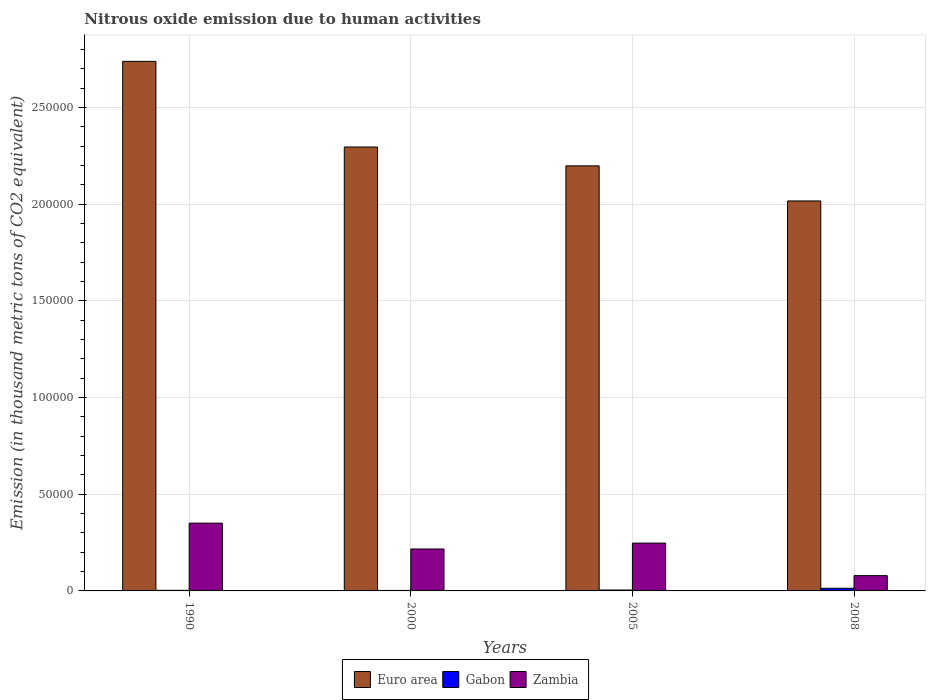How many groups of bars are there?
Ensure brevity in your answer.  4. Are the number of bars on each tick of the X-axis equal?
Your response must be concise. Yes. How many bars are there on the 1st tick from the left?
Make the answer very short. 3. How many bars are there on the 3rd tick from the right?
Your answer should be very brief. 3. In how many cases, is the number of bars for a given year not equal to the number of legend labels?
Offer a very short reply. 0. What is the amount of nitrous oxide emitted in Euro area in 2008?
Give a very brief answer. 2.02e+05. Across all years, what is the maximum amount of nitrous oxide emitted in Gabon?
Your answer should be compact. 1370. Across all years, what is the minimum amount of nitrous oxide emitted in Zambia?
Keep it short and to the point. 7906.4. In which year was the amount of nitrous oxide emitted in Euro area maximum?
Offer a very short reply. 1990. What is the total amount of nitrous oxide emitted in Euro area in the graph?
Your answer should be very brief. 9.25e+05. What is the difference between the amount of nitrous oxide emitted in Zambia in 1990 and that in 2005?
Provide a short and direct response. 1.03e+04. What is the difference between the amount of nitrous oxide emitted in Euro area in 2005 and the amount of nitrous oxide emitted in Gabon in 1990?
Offer a terse response. 2.19e+05. What is the average amount of nitrous oxide emitted in Gabon per year?
Ensure brevity in your answer.  602.27. In the year 2000, what is the difference between the amount of nitrous oxide emitted in Zambia and amount of nitrous oxide emitted in Gabon?
Give a very brief answer. 2.14e+04. In how many years, is the amount of nitrous oxide emitted in Euro area greater than 250000 thousand metric tons?
Your answer should be compact. 1. What is the ratio of the amount of nitrous oxide emitted in Euro area in 1990 to that in 2005?
Keep it short and to the point. 1.25. Is the difference between the amount of nitrous oxide emitted in Zambia in 1990 and 2008 greater than the difference between the amount of nitrous oxide emitted in Gabon in 1990 and 2008?
Your answer should be compact. Yes. What is the difference between the highest and the second highest amount of nitrous oxide emitted in Gabon?
Provide a succinct answer. 892.9. What is the difference between the highest and the lowest amount of nitrous oxide emitted in Gabon?
Your response must be concise. 1115.1. In how many years, is the amount of nitrous oxide emitted in Euro area greater than the average amount of nitrous oxide emitted in Euro area taken over all years?
Offer a terse response. 1. What does the 1st bar from the left in 2008 represents?
Your answer should be very brief. Euro area. What does the 1st bar from the right in 2000 represents?
Your answer should be compact. Zambia. Is it the case that in every year, the sum of the amount of nitrous oxide emitted in Euro area and amount of nitrous oxide emitted in Zambia is greater than the amount of nitrous oxide emitted in Gabon?
Provide a short and direct response. Yes. Are all the bars in the graph horizontal?
Your answer should be compact. No. Are the values on the major ticks of Y-axis written in scientific E-notation?
Provide a short and direct response. No. Does the graph contain grids?
Make the answer very short. Yes. How many legend labels are there?
Make the answer very short. 3. How are the legend labels stacked?
Offer a very short reply. Horizontal. What is the title of the graph?
Offer a very short reply. Nitrous oxide emission due to human activities. Does "Heavily indebted poor countries" appear as one of the legend labels in the graph?
Your answer should be compact. No. What is the label or title of the X-axis?
Your answer should be compact. Years. What is the label or title of the Y-axis?
Ensure brevity in your answer.  Emission (in thousand metric tons of CO2 equivalent). What is the Emission (in thousand metric tons of CO2 equivalent) of Euro area in 1990?
Your answer should be compact. 2.74e+05. What is the Emission (in thousand metric tons of CO2 equivalent) of Gabon in 1990?
Ensure brevity in your answer.  307.1. What is the Emission (in thousand metric tons of CO2 equivalent) in Zambia in 1990?
Offer a terse response. 3.50e+04. What is the Emission (in thousand metric tons of CO2 equivalent) in Euro area in 2000?
Offer a terse response. 2.30e+05. What is the Emission (in thousand metric tons of CO2 equivalent) in Gabon in 2000?
Offer a terse response. 254.9. What is the Emission (in thousand metric tons of CO2 equivalent) in Zambia in 2000?
Your answer should be very brief. 2.17e+04. What is the Emission (in thousand metric tons of CO2 equivalent) in Euro area in 2005?
Make the answer very short. 2.20e+05. What is the Emission (in thousand metric tons of CO2 equivalent) of Gabon in 2005?
Give a very brief answer. 477.1. What is the Emission (in thousand metric tons of CO2 equivalent) of Zambia in 2005?
Your response must be concise. 2.47e+04. What is the Emission (in thousand metric tons of CO2 equivalent) in Euro area in 2008?
Give a very brief answer. 2.02e+05. What is the Emission (in thousand metric tons of CO2 equivalent) in Gabon in 2008?
Keep it short and to the point. 1370. What is the Emission (in thousand metric tons of CO2 equivalent) of Zambia in 2008?
Ensure brevity in your answer.  7906.4. Across all years, what is the maximum Emission (in thousand metric tons of CO2 equivalent) of Euro area?
Offer a very short reply. 2.74e+05. Across all years, what is the maximum Emission (in thousand metric tons of CO2 equivalent) in Gabon?
Keep it short and to the point. 1370. Across all years, what is the maximum Emission (in thousand metric tons of CO2 equivalent) in Zambia?
Your response must be concise. 3.50e+04. Across all years, what is the minimum Emission (in thousand metric tons of CO2 equivalent) in Euro area?
Provide a short and direct response. 2.02e+05. Across all years, what is the minimum Emission (in thousand metric tons of CO2 equivalent) in Gabon?
Your response must be concise. 254.9. Across all years, what is the minimum Emission (in thousand metric tons of CO2 equivalent) in Zambia?
Give a very brief answer. 7906.4. What is the total Emission (in thousand metric tons of CO2 equivalent) in Euro area in the graph?
Your response must be concise. 9.25e+05. What is the total Emission (in thousand metric tons of CO2 equivalent) of Gabon in the graph?
Your answer should be very brief. 2409.1. What is the total Emission (in thousand metric tons of CO2 equivalent) of Zambia in the graph?
Your response must be concise. 8.94e+04. What is the difference between the Emission (in thousand metric tons of CO2 equivalent) in Euro area in 1990 and that in 2000?
Your response must be concise. 4.43e+04. What is the difference between the Emission (in thousand metric tons of CO2 equivalent) of Gabon in 1990 and that in 2000?
Your response must be concise. 52.2. What is the difference between the Emission (in thousand metric tons of CO2 equivalent) in Zambia in 1990 and that in 2000?
Offer a terse response. 1.33e+04. What is the difference between the Emission (in thousand metric tons of CO2 equivalent) of Euro area in 1990 and that in 2005?
Offer a very short reply. 5.40e+04. What is the difference between the Emission (in thousand metric tons of CO2 equivalent) in Gabon in 1990 and that in 2005?
Your answer should be compact. -170. What is the difference between the Emission (in thousand metric tons of CO2 equivalent) of Zambia in 1990 and that in 2005?
Your answer should be very brief. 1.03e+04. What is the difference between the Emission (in thousand metric tons of CO2 equivalent) in Euro area in 1990 and that in 2008?
Make the answer very short. 7.22e+04. What is the difference between the Emission (in thousand metric tons of CO2 equivalent) of Gabon in 1990 and that in 2008?
Your response must be concise. -1062.9. What is the difference between the Emission (in thousand metric tons of CO2 equivalent) in Zambia in 1990 and that in 2008?
Make the answer very short. 2.71e+04. What is the difference between the Emission (in thousand metric tons of CO2 equivalent) in Euro area in 2000 and that in 2005?
Your answer should be compact. 9758.6. What is the difference between the Emission (in thousand metric tons of CO2 equivalent) of Gabon in 2000 and that in 2005?
Offer a very short reply. -222.2. What is the difference between the Emission (in thousand metric tons of CO2 equivalent) in Zambia in 2000 and that in 2005?
Your response must be concise. -3036.8. What is the difference between the Emission (in thousand metric tons of CO2 equivalent) of Euro area in 2000 and that in 2008?
Keep it short and to the point. 2.79e+04. What is the difference between the Emission (in thousand metric tons of CO2 equivalent) of Gabon in 2000 and that in 2008?
Provide a short and direct response. -1115.1. What is the difference between the Emission (in thousand metric tons of CO2 equivalent) in Zambia in 2000 and that in 2008?
Offer a terse response. 1.38e+04. What is the difference between the Emission (in thousand metric tons of CO2 equivalent) in Euro area in 2005 and that in 2008?
Make the answer very short. 1.81e+04. What is the difference between the Emission (in thousand metric tons of CO2 equivalent) of Gabon in 2005 and that in 2008?
Your answer should be compact. -892.9. What is the difference between the Emission (in thousand metric tons of CO2 equivalent) in Zambia in 2005 and that in 2008?
Your answer should be compact. 1.68e+04. What is the difference between the Emission (in thousand metric tons of CO2 equivalent) of Euro area in 1990 and the Emission (in thousand metric tons of CO2 equivalent) of Gabon in 2000?
Offer a very short reply. 2.74e+05. What is the difference between the Emission (in thousand metric tons of CO2 equivalent) of Euro area in 1990 and the Emission (in thousand metric tons of CO2 equivalent) of Zambia in 2000?
Offer a terse response. 2.52e+05. What is the difference between the Emission (in thousand metric tons of CO2 equivalent) of Gabon in 1990 and the Emission (in thousand metric tons of CO2 equivalent) of Zambia in 2000?
Make the answer very short. -2.14e+04. What is the difference between the Emission (in thousand metric tons of CO2 equivalent) in Euro area in 1990 and the Emission (in thousand metric tons of CO2 equivalent) in Gabon in 2005?
Ensure brevity in your answer.  2.73e+05. What is the difference between the Emission (in thousand metric tons of CO2 equivalent) in Euro area in 1990 and the Emission (in thousand metric tons of CO2 equivalent) in Zambia in 2005?
Provide a succinct answer. 2.49e+05. What is the difference between the Emission (in thousand metric tons of CO2 equivalent) in Gabon in 1990 and the Emission (in thousand metric tons of CO2 equivalent) in Zambia in 2005?
Provide a succinct answer. -2.44e+04. What is the difference between the Emission (in thousand metric tons of CO2 equivalent) of Euro area in 1990 and the Emission (in thousand metric tons of CO2 equivalent) of Gabon in 2008?
Offer a terse response. 2.72e+05. What is the difference between the Emission (in thousand metric tons of CO2 equivalent) of Euro area in 1990 and the Emission (in thousand metric tons of CO2 equivalent) of Zambia in 2008?
Provide a succinct answer. 2.66e+05. What is the difference between the Emission (in thousand metric tons of CO2 equivalent) of Gabon in 1990 and the Emission (in thousand metric tons of CO2 equivalent) of Zambia in 2008?
Ensure brevity in your answer.  -7599.3. What is the difference between the Emission (in thousand metric tons of CO2 equivalent) in Euro area in 2000 and the Emission (in thousand metric tons of CO2 equivalent) in Gabon in 2005?
Offer a terse response. 2.29e+05. What is the difference between the Emission (in thousand metric tons of CO2 equivalent) in Euro area in 2000 and the Emission (in thousand metric tons of CO2 equivalent) in Zambia in 2005?
Ensure brevity in your answer.  2.05e+05. What is the difference between the Emission (in thousand metric tons of CO2 equivalent) of Gabon in 2000 and the Emission (in thousand metric tons of CO2 equivalent) of Zambia in 2005?
Give a very brief answer. -2.45e+04. What is the difference between the Emission (in thousand metric tons of CO2 equivalent) of Euro area in 2000 and the Emission (in thousand metric tons of CO2 equivalent) of Gabon in 2008?
Your answer should be very brief. 2.28e+05. What is the difference between the Emission (in thousand metric tons of CO2 equivalent) in Euro area in 2000 and the Emission (in thousand metric tons of CO2 equivalent) in Zambia in 2008?
Your answer should be compact. 2.22e+05. What is the difference between the Emission (in thousand metric tons of CO2 equivalent) of Gabon in 2000 and the Emission (in thousand metric tons of CO2 equivalent) of Zambia in 2008?
Offer a terse response. -7651.5. What is the difference between the Emission (in thousand metric tons of CO2 equivalent) in Euro area in 2005 and the Emission (in thousand metric tons of CO2 equivalent) in Gabon in 2008?
Give a very brief answer. 2.18e+05. What is the difference between the Emission (in thousand metric tons of CO2 equivalent) of Euro area in 2005 and the Emission (in thousand metric tons of CO2 equivalent) of Zambia in 2008?
Your answer should be very brief. 2.12e+05. What is the difference between the Emission (in thousand metric tons of CO2 equivalent) in Gabon in 2005 and the Emission (in thousand metric tons of CO2 equivalent) in Zambia in 2008?
Offer a very short reply. -7429.3. What is the average Emission (in thousand metric tons of CO2 equivalent) of Euro area per year?
Provide a short and direct response. 2.31e+05. What is the average Emission (in thousand metric tons of CO2 equivalent) of Gabon per year?
Provide a succinct answer. 602.27. What is the average Emission (in thousand metric tons of CO2 equivalent) of Zambia per year?
Your response must be concise. 2.23e+04. In the year 1990, what is the difference between the Emission (in thousand metric tons of CO2 equivalent) in Euro area and Emission (in thousand metric tons of CO2 equivalent) in Gabon?
Keep it short and to the point. 2.73e+05. In the year 1990, what is the difference between the Emission (in thousand metric tons of CO2 equivalent) of Euro area and Emission (in thousand metric tons of CO2 equivalent) of Zambia?
Offer a very short reply. 2.39e+05. In the year 1990, what is the difference between the Emission (in thousand metric tons of CO2 equivalent) in Gabon and Emission (in thousand metric tons of CO2 equivalent) in Zambia?
Your response must be concise. -3.47e+04. In the year 2000, what is the difference between the Emission (in thousand metric tons of CO2 equivalent) of Euro area and Emission (in thousand metric tons of CO2 equivalent) of Gabon?
Your answer should be compact. 2.29e+05. In the year 2000, what is the difference between the Emission (in thousand metric tons of CO2 equivalent) of Euro area and Emission (in thousand metric tons of CO2 equivalent) of Zambia?
Offer a very short reply. 2.08e+05. In the year 2000, what is the difference between the Emission (in thousand metric tons of CO2 equivalent) in Gabon and Emission (in thousand metric tons of CO2 equivalent) in Zambia?
Give a very brief answer. -2.14e+04. In the year 2005, what is the difference between the Emission (in thousand metric tons of CO2 equivalent) in Euro area and Emission (in thousand metric tons of CO2 equivalent) in Gabon?
Offer a terse response. 2.19e+05. In the year 2005, what is the difference between the Emission (in thousand metric tons of CO2 equivalent) in Euro area and Emission (in thousand metric tons of CO2 equivalent) in Zambia?
Keep it short and to the point. 1.95e+05. In the year 2005, what is the difference between the Emission (in thousand metric tons of CO2 equivalent) in Gabon and Emission (in thousand metric tons of CO2 equivalent) in Zambia?
Provide a short and direct response. -2.42e+04. In the year 2008, what is the difference between the Emission (in thousand metric tons of CO2 equivalent) of Euro area and Emission (in thousand metric tons of CO2 equivalent) of Gabon?
Your answer should be compact. 2.00e+05. In the year 2008, what is the difference between the Emission (in thousand metric tons of CO2 equivalent) of Euro area and Emission (in thousand metric tons of CO2 equivalent) of Zambia?
Your answer should be compact. 1.94e+05. In the year 2008, what is the difference between the Emission (in thousand metric tons of CO2 equivalent) of Gabon and Emission (in thousand metric tons of CO2 equivalent) of Zambia?
Provide a succinct answer. -6536.4. What is the ratio of the Emission (in thousand metric tons of CO2 equivalent) in Euro area in 1990 to that in 2000?
Provide a short and direct response. 1.19. What is the ratio of the Emission (in thousand metric tons of CO2 equivalent) of Gabon in 1990 to that in 2000?
Provide a succinct answer. 1.2. What is the ratio of the Emission (in thousand metric tons of CO2 equivalent) of Zambia in 1990 to that in 2000?
Your response must be concise. 1.62. What is the ratio of the Emission (in thousand metric tons of CO2 equivalent) in Euro area in 1990 to that in 2005?
Ensure brevity in your answer.  1.25. What is the ratio of the Emission (in thousand metric tons of CO2 equivalent) of Gabon in 1990 to that in 2005?
Your answer should be compact. 0.64. What is the ratio of the Emission (in thousand metric tons of CO2 equivalent) in Zambia in 1990 to that in 2005?
Make the answer very short. 1.42. What is the ratio of the Emission (in thousand metric tons of CO2 equivalent) in Euro area in 1990 to that in 2008?
Ensure brevity in your answer.  1.36. What is the ratio of the Emission (in thousand metric tons of CO2 equivalent) in Gabon in 1990 to that in 2008?
Offer a very short reply. 0.22. What is the ratio of the Emission (in thousand metric tons of CO2 equivalent) of Zambia in 1990 to that in 2008?
Offer a terse response. 4.43. What is the ratio of the Emission (in thousand metric tons of CO2 equivalent) in Euro area in 2000 to that in 2005?
Your answer should be very brief. 1.04. What is the ratio of the Emission (in thousand metric tons of CO2 equivalent) in Gabon in 2000 to that in 2005?
Provide a short and direct response. 0.53. What is the ratio of the Emission (in thousand metric tons of CO2 equivalent) of Zambia in 2000 to that in 2005?
Keep it short and to the point. 0.88. What is the ratio of the Emission (in thousand metric tons of CO2 equivalent) in Euro area in 2000 to that in 2008?
Provide a short and direct response. 1.14. What is the ratio of the Emission (in thousand metric tons of CO2 equivalent) of Gabon in 2000 to that in 2008?
Offer a very short reply. 0.19. What is the ratio of the Emission (in thousand metric tons of CO2 equivalent) in Zambia in 2000 to that in 2008?
Offer a very short reply. 2.74. What is the ratio of the Emission (in thousand metric tons of CO2 equivalent) of Euro area in 2005 to that in 2008?
Offer a very short reply. 1.09. What is the ratio of the Emission (in thousand metric tons of CO2 equivalent) of Gabon in 2005 to that in 2008?
Offer a very short reply. 0.35. What is the ratio of the Emission (in thousand metric tons of CO2 equivalent) in Zambia in 2005 to that in 2008?
Your answer should be very brief. 3.13. What is the difference between the highest and the second highest Emission (in thousand metric tons of CO2 equivalent) in Euro area?
Keep it short and to the point. 4.43e+04. What is the difference between the highest and the second highest Emission (in thousand metric tons of CO2 equivalent) of Gabon?
Keep it short and to the point. 892.9. What is the difference between the highest and the second highest Emission (in thousand metric tons of CO2 equivalent) in Zambia?
Ensure brevity in your answer.  1.03e+04. What is the difference between the highest and the lowest Emission (in thousand metric tons of CO2 equivalent) of Euro area?
Keep it short and to the point. 7.22e+04. What is the difference between the highest and the lowest Emission (in thousand metric tons of CO2 equivalent) of Gabon?
Your answer should be very brief. 1115.1. What is the difference between the highest and the lowest Emission (in thousand metric tons of CO2 equivalent) in Zambia?
Your answer should be very brief. 2.71e+04. 